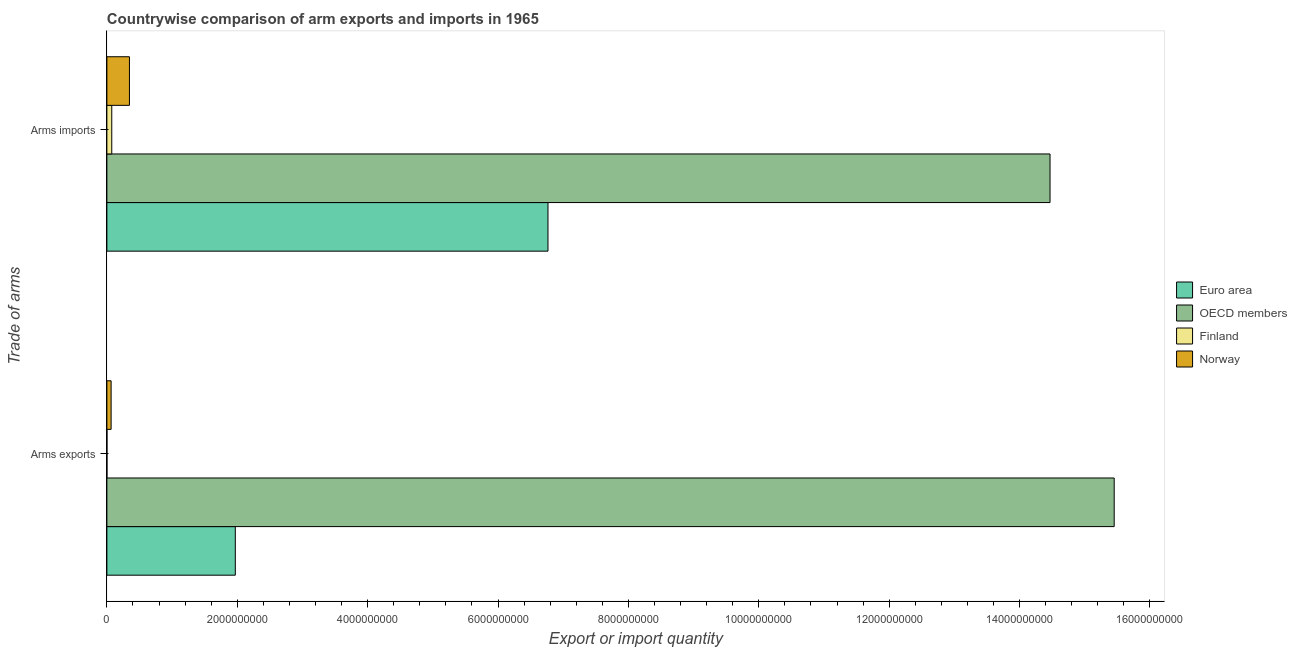How many different coloured bars are there?
Your answer should be compact. 4. How many bars are there on the 2nd tick from the bottom?
Offer a very short reply. 4. What is the label of the 2nd group of bars from the top?
Your answer should be compact. Arms exports. What is the arms exports in OECD members?
Ensure brevity in your answer.  1.55e+1. Across all countries, what is the maximum arms imports?
Give a very brief answer. 1.45e+1. Across all countries, what is the minimum arms imports?
Provide a short and direct response. 7.50e+07. In which country was the arms imports maximum?
Give a very brief answer. OECD members. In which country was the arms exports minimum?
Ensure brevity in your answer.  Finland. What is the total arms imports in the graph?
Your answer should be very brief. 2.17e+1. What is the difference between the arms imports in Norway and that in Euro area?
Offer a very short reply. -6.42e+09. What is the difference between the arms exports in OECD members and the arms imports in Euro area?
Your answer should be compact. 8.68e+09. What is the average arms exports per country?
Make the answer very short. 4.37e+09. What is the difference between the arms exports and arms imports in Euro area?
Make the answer very short. -4.80e+09. What is the ratio of the arms exports in Norway to that in OECD members?
Provide a short and direct response. 0. In how many countries, is the arms exports greater than the average arms exports taken over all countries?
Provide a short and direct response. 1. What does the 3rd bar from the bottom in Arms exports represents?
Ensure brevity in your answer.  Finland. How many bars are there?
Your answer should be compact. 8. Are the values on the major ticks of X-axis written in scientific E-notation?
Your answer should be very brief. No. Does the graph contain any zero values?
Ensure brevity in your answer.  No. How many legend labels are there?
Your answer should be very brief. 4. How are the legend labels stacked?
Your answer should be compact. Vertical. What is the title of the graph?
Make the answer very short. Countrywise comparison of arm exports and imports in 1965. Does "Kyrgyz Republic" appear as one of the legend labels in the graph?
Your answer should be very brief. No. What is the label or title of the X-axis?
Offer a very short reply. Export or import quantity. What is the label or title of the Y-axis?
Your answer should be compact. Trade of arms. What is the Export or import quantity of Euro area in Arms exports?
Your answer should be very brief. 1.97e+09. What is the Export or import quantity in OECD members in Arms exports?
Provide a succinct answer. 1.55e+1. What is the Export or import quantity of Norway in Arms exports?
Provide a succinct answer. 6.50e+07. What is the Export or import quantity in Euro area in Arms imports?
Give a very brief answer. 6.77e+09. What is the Export or import quantity in OECD members in Arms imports?
Offer a very short reply. 1.45e+1. What is the Export or import quantity in Finland in Arms imports?
Provide a succinct answer. 7.50e+07. What is the Export or import quantity of Norway in Arms imports?
Your answer should be very brief. 3.46e+08. Across all Trade of arms, what is the maximum Export or import quantity of Euro area?
Provide a short and direct response. 6.77e+09. Across all Trade of arms, what is the maximum Export or import quantity in OECD members?
Give a very brief answer. 1.55e+1. Across all Trade of arms, what is the maximum Export or import quantity in Finland?
Offer a very short reply. 7.50e+07. Across all Trade of arms, what is the maximum Export or import quantity in Norway?
Your answer should be compact. 3.46e+08. Across all Trade of arms, what is the minimum Export or import quantity of Euro area?
Keep it short and to the point. 1.97e+09. Across all Trade of arms, what is the minimum Export or import quantity in OECD members?
Your answer should be very brief. 1.45e+1. Across all Trade of arms, what is the minimum Export or import quantity in Finland?
Keep it short and to the point. 1.00e+06. Across all Trade of arms, what is the minimum Export or import quantity of Norway?
Provide a short and direct response. 6.50e+07. What is the total Export or import quantity in Euro area in the graph?
Your answer should be compact. 8.74e+09. What is the total Export or import quantity in OECD members in the graph?
Ensure brevity in your answer.  2.99e+1. What is the total Export or import quantity of Finland in the graph?
Provide a short and direct response. 7.60e+07. What is the total Export or import quantity in Norway in the graph?
Ensure brevity in your answer.  4.11e+08. What is the difference between the Export or import quantity of Euro area in Arms exports and that in Arms imports?
Give a very brief answer. -4.80e+09. What is the difference between the Export or import quantity in OECD members in Arms exports and that in Arms imports?
Your answer should be compact. 9.84e+08. What is the difference between the Export or import quantity in Finland in Arms exports and that in Arms imports?
Your response must be concise. -7.40e+07. What is the difference between the Export or import quantity of Norway in Arms exports and that in Arms imports?
Your response must be concise. -2.81e+08. What is the difference between the Export or import quantity of Euro area in Arms exports and the Export or import quantity of OECD members in Arms imports?
Provide a succinct answer. -1.25e+1. What is the difference between the Export or import quantity in Euro area in Arms exports and the Export or import quantity in Finland in Arms imports?
Provide a short and direct response. 1.90e+09. What is the difference between the Export or import quantity in Euro area in Arms exports and the Export or import quantity in Norway in Arms imports?
Make the answer very short. 1.62e+09. What is the difference between the Export or import quantity of OECD members in Arms exports and the Export or import quantity of Finland in Arms imports?
Provide a succinct answer. 1.54e+1. What is the difference between the Export or import quantity in OECD members in Arms exports and the Export or import quantity in Norway in Arms imports?
Ensure brevity in your answer.  1.51e+1. What is the difference between the Export or import quantity in Finland in Arms exports and the Export or import quantity in Norway in Arms imports?
Give a very brief answer. -3.45e+08. What is the average Export or import quantity of Euro area per Trade of arms?
Keep it short and to the point. 4.37e+09. What is the average Export or import quantity in OECD members per Trade of arms?
Provide a succinct answer. 1.50e+1. What is the average Export or import quantity of Finland per Trade of arms?
Your answer should be compact. 3.80e+07. What is the average Export or import quantity in Norway per Trade of arms?
Offer a terse response. 2.06e+08. What is the difference between the Export or import quantity of Euro area and Export or import quantity of OECD members in Arms exports?
Your answer should be very brief. -1.35e+1. What is the difference between the Export or import quantity in Euro area and Export or import quantity in Finland in Arms exports?
Provide a succinct answer. 1.97e+09. What is the difference between the Export or import quantity of Euro area and Export or import quantity of Norway in Arms exports?
Keep it short and to the point. 1.90e+09. What is the difference between the Export or import quantity in OECD members and Export or import quantity in Finland in Arms exports?
Provide a succinct answer. 1.54e+1. What is the difference between the Export or import quantity in OECD members and Export or import quantity in Norway in Arms exports?
Offer a very short reply. 1.54e+1. What is the difference between the Export or import quantity in Finland and Export or import quantity in Norway in Arms exports?
Make the answer very short. -6.40e+07. What is the difference between the Export or import quantity of Euro area and Export or import quantity of OECD members in Arms imports?
Your response must be concise. -7.70e+09. What is the difference between the Export or import quantity of Euro area and Export or import quantity of Finland in Arms imports?
Keep it short and to the point. 6.69e+09. What is the difference between the Export or import quantity in Euro area and Export or import quantity in Norway in Arms imports?
Make the answer very short. 6.42e+09. What is the difference between the Export or import quantity of OECD members and Export or import quantity of Finland in Arms imports?
Offer a terse response. 1.44e+1. What is the difference between the Export or import quantity of OECD members and Export or import quantity of Norway in Arms imports?
Make the answer very short. 1.41e+1. What is the difference between the Export or import quantity in Finland and Export or import quantity in Norway in Arms imports?
Your response must be concise. -2.71e+08. What is the ratio of the Export or import quantity in Euro area in Arms exports to that in Arms imports?
Make the answer very short. 0.29. What is the ratio of the Export or import quantity of OECD members in Arms exports to that in Arms imports?
Your answer should be compact. 1.07. What is the ratio of the Export or import quantity in Finland in Arms exports to that in Arms imports?
Offer a terse response. 0.01. What is the ratio of the Export or import quantity of Norway in Arms exports to that in Arms imports?
Offer a very short reply. 0.19. What is the difference between the highest and the second highest Export or import quantity in Euro area?
Provide a short and direct response. 4.80e+09. What is the difference between the highest and the second highest Export or import quantity of OECD members?
Keep it short and to the point. 9.84e+08. What is the difference between the highest and the second highest Export or import quantity in Finland?
Keep it short and to the point. 7.40e+07. What is the difference between the highest and the second highest Export or import quantity in Norway?
Make the answer very short. 2.81e+08. What is the difference between the highest and the lowest Export or import quantity in Euro area?
Ensure brevity in your answer.  4.80e+09. What is the difference between the highest and the lowest Export or import quantity in OECD members?
Your answer should be compact. 9.84e+08. What is the difference between the highest and the lowest Export or import quantity of Finland?
Provide a succinct answer. 7.40e+07. What is the difference between the highest and the lowest Export or import quantity in Norway?
Offer a very short reply. 2.81e+08. 